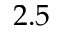<formula> <loc_0><loc_0><loc_500><loc_500>2 . 5</formula> 